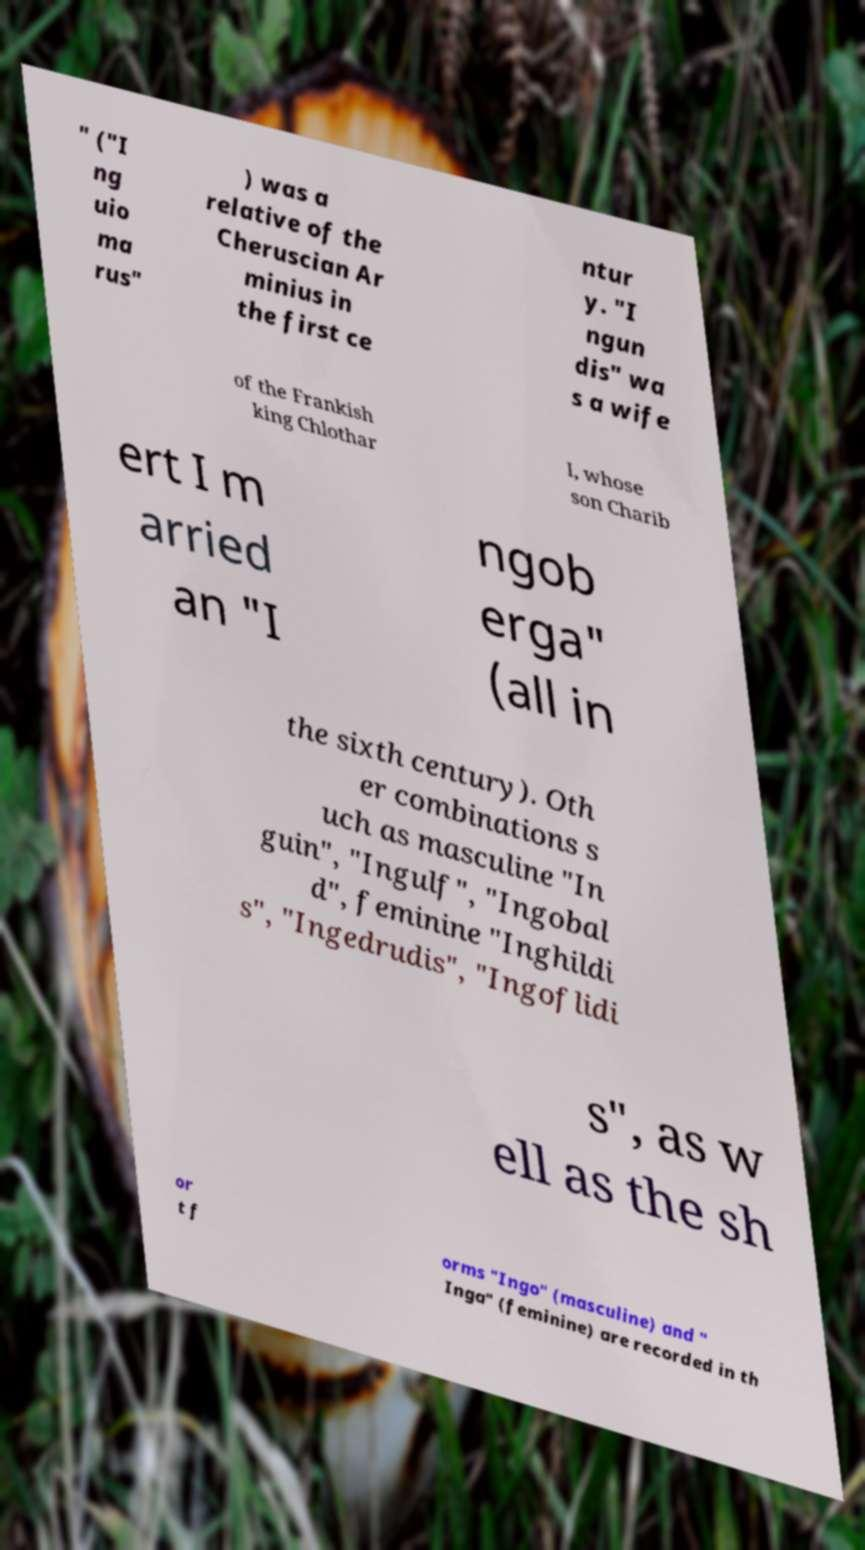Can you accurately transcribe the text from the provided image for me? " ("I ng uio ma rus" ) was a relative of the Cheruscian Ar minius in the first ce ntur y. "I ngun dis" wa s a wife of the Frankish king Chlothar I, whose son Charib ert I m arried an "I ngob erga" (all in the sixth century). Oth er combinations s uch as masculine "In guin", "Ingulf", "Ingobal d", feminine "Inghildi s", "Ingedrudis", "Ingoflidi s", as w ell as the sh or t f orms "Ingo" (masculine) and " Inga" (feminine) are recorded in th 